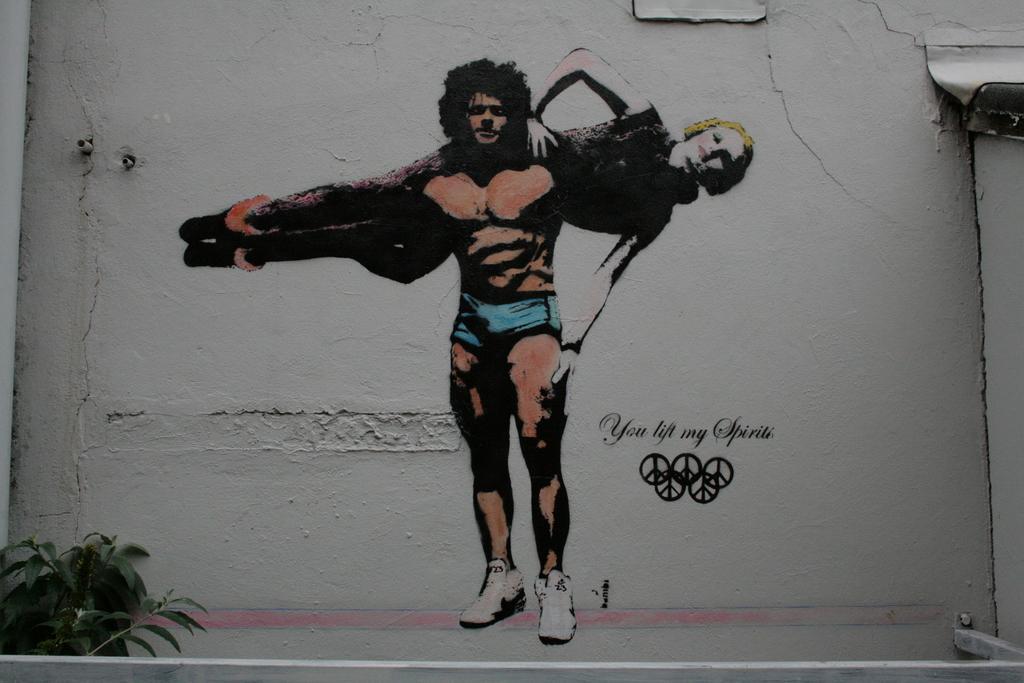Please provide a concise description of this image. There is a painting on the wall. Here we can see man is lifting a woman. On the right side of the image, we can see some text and symbol. Left side bottom, we can see plant leaves and stems. 